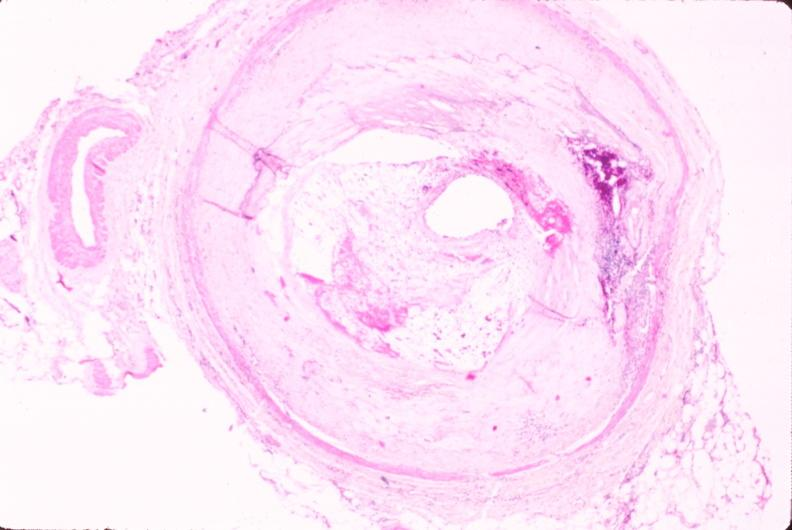s marked present?
Answer the question using a single word or phrase. No 